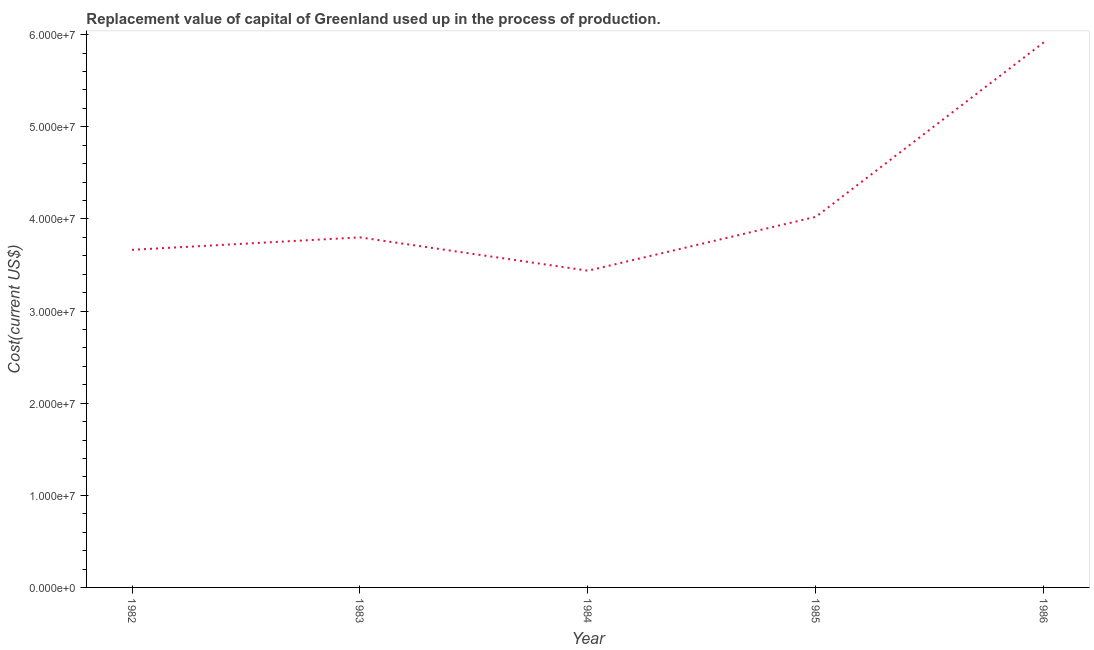What is the consumption of fixed capital in 1983?
Ensure brevity in your answer.  3.80e+07. Across all years, what is the maximum consumption of fixed capital?
Offer a terse response. 5.92e+07. Across all years, what is the minimum consumption of fixed capital?
Keep it short and to the point. 3.44e+07. What is the sum of the consumption of fixed capital?
Give a very brief answer. 2.08e+08. What is the difference between the consumption of fixed capital in 1983 and 1986?
Your answer should be compact. -2.12e+07. What is the average consumption of fixed capital per year?
Your answer should be compact. 4.17e+07. What is the median consumption of fixed capital?
Ensure brevity in your answer.  3.80e+07. In how many years, is the consumption of fixed capital greater than 50000000 US$?
Give a very brief answer. 1. What is the ratio of the consumption of fixed capital in 1982 to that in 1983?
Offer a very short reply. 0.96. Is the consumption of fixed capital in 1983 less than that in 1984?
Provide a short and direct response. No. What is the difference between the highest and the second highest consumption of fixed capital?
Offer a very short reply. 1.89e+07. What is the difference between the highest and the lowest consumption of fixed capital?
Provide a succinct answer. 2.48e+07. In how many years, is the consumption of fixed capital greater than the average consumption of fixed capital taken over all years?
Your response must be concise. 1. How many lines are there?
Provide a succinct answer. 1. Are the values on the major ticks of Y-axis written in scientific E-notation?
Your response must be concise. Yes. What is the title of the graph?
Provide a succinct answer. Replacement value of capital of Greenland used up in the process of production. What is the label or title of the Y-axis?
Your answer should be compact. Cost(current US$). What is the Cost(current US$) of 1982?
Give a very brief answer. 3.66e+07. What is the Cost(current US$) in 1983?
Your answer should be compact. 3.80e+07. What is the Cost(current US$) of 1984?
Your answer should be very brief. 3.44e+07. What is the Cost(current US$) of 1985?
Provide a succinct answer. 4.02e+07. What is the Cost(current US$) of 1986?
Offer a terse response. 5.92e+07. What is the difference between the Cost(current US$) in 1982 and 1983?
Offer a very short reply. -1.35e+06. What is the difference between the Cost(current US$) in 1982 and 1984?
Provide a succinct answer. 2.26e+06. What is the difference between the Cost(current US$) in 1982 and 1985?
Make the answer very short. -3.58e+06. What is the difference between the Cost(current US$) in 1982 and 1986?
Ensure brevity in your answer.  -2.25e+07. What is the difference between the Cost(current US$) in 1983 and 1984?
Ensure brevity in your answer.  3.62e+06. What is the difference between the Cost(current US$) in 1983 and 1985?
Offer a very short reply. -2.23e+06. What is the difference between the Cost(current US$) in 1983 and 1986?
Make the answer very short. -2.12e+07. What is the difference between the Cost(current US$) in 1984 and 1985?
Your response must be concise. -5.85e+06. What is the difference between the Cost(current US$) in 1984 and 1986?
Offer a terse response. -2.48e+07. What is the difference between the Cost(current US$) in 1985 and 1986?
Offer a very short reply. -1.89e+07. What is the ratio of the Cost(current US$) in 1982 to that in 1983?
Your answer should be very brief. 0.96. What is the ratio of the Cost(current US$) in 1982 to that in 1984?
Your answer should be compact. 1.07. What is the ratio of the Cost(current US$) in 1982 to that in 1985?
Make the answer very short. 0.91. What is the ratio of the Cost(current US$) in 1982 to that in 1986?
Your answer should be compact. 0.62. What is the ratio of the Cost(current US$) in 1983 to that in 1984?
Provide a short and direct response. 1.1. What is the ratio of the Cost(current US$) in 1983 to that in 1985?
Offer a very short reply. 0.94. What is the ratio of the Cost(current US$) in 1983 to that in 1986?
Provide a short and direct response. 0.64. What is the ratio of the Cost(current US$) in 1984 to that in 1985?
Keep it short and to the point. 0.85. What is the ratio of the Cost(current US$) in 1984 to that in 1986?
Ensure brevity in your answer.  0.58. What is the ratio of the Cost(current US$) in 1985 to that in 1986?
Make the answer very short. 0.68. 